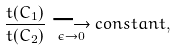Convert formula to latex. <formula><loc_0><loc_0><loc_500><loc_500>\frac { t ( C _ { 1 } ) } { t ( C _ { 2 } ) } \underset { \epsilon \rightarrow 0 } { \longrightarrow } { c o n s t a n t } ,</formula> 